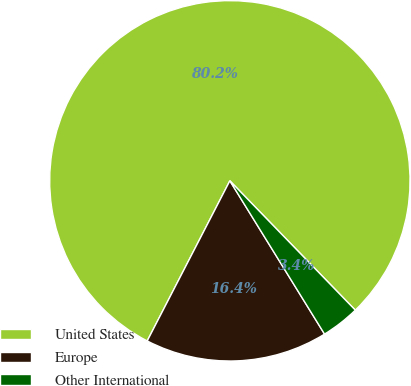<chart> <loc_0><loc_0><loc_500><loc_500><pie_chart><fcel>United States<fcel>Europe<fcel>Other International<nl><fcel>80.16%<fcel>16.39%<fcel>3.45%<nl></chart> 